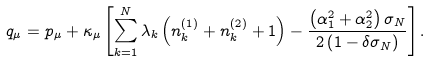<formula> <loc_0><loc_0><loc_500><loc_500>q _ { \mu } = p _ { \mu } + \kappa _ { \mu } \left [ \sum _ { k = 1 } ^ { N } \lambda _ { k } \left ( n _ { k } ^ { ( 1 ) } + n _ { k } ^ { ( 2 ) } + 1 \right ) - \frac { \left ( \alpha _ { 1 } ^ { 2 } + \alpha _ { 2 } ^ { 2 } \right ) \sigma _ { N } } { 2 \left ( 1 - \delta \sigma _ { N } \right ) } \right ] .</formula> 